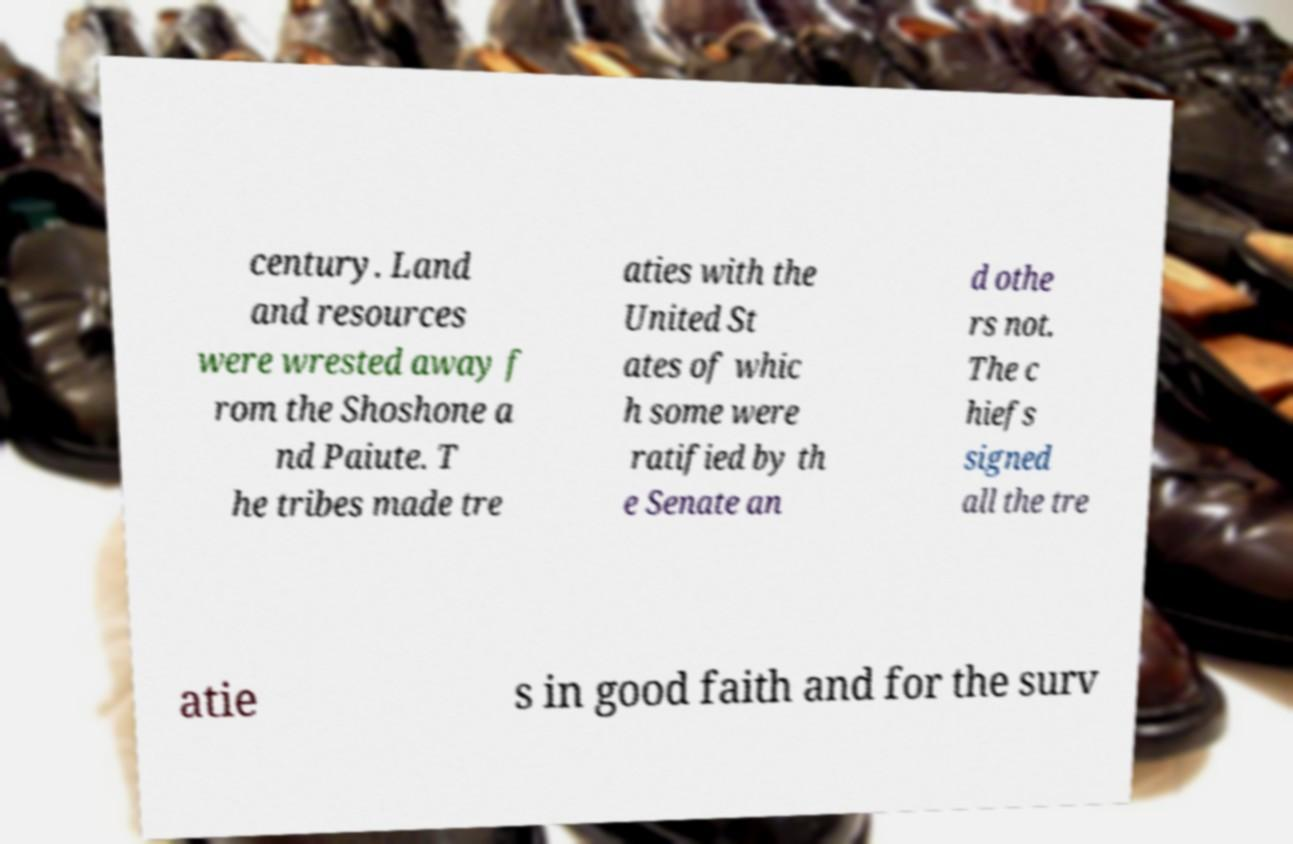Please identify and transcribe the text found in this image. century. Land and resources were wrested away f rom the Shoshone a nd Paiute. T he tribes made tre aties with the United St ates of whic h some were ratified by th e Senate an d othe rs not. The c hiefs signed all the tre atie s in good faith and for the surv 